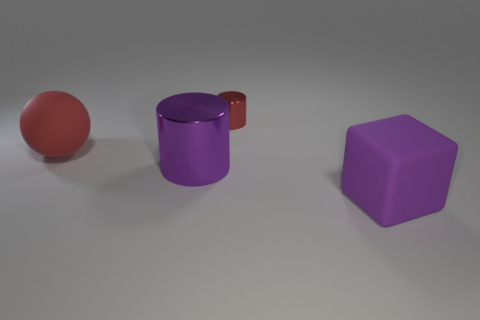Add 4 large rubber things. How many objects exist? 8 Subtract all balls. How many objects are left? 3 Add 1 large yellow rubber spheres. How many large yellow rubber spheres exist? 1 Subtract 0 yellow spheres. How many objects are left? 4 Subtract all tiny yellow blocks. Subtract all purple things. How many objects are left? 2 Add 2 big purple things. How many big purple things are left? 4 